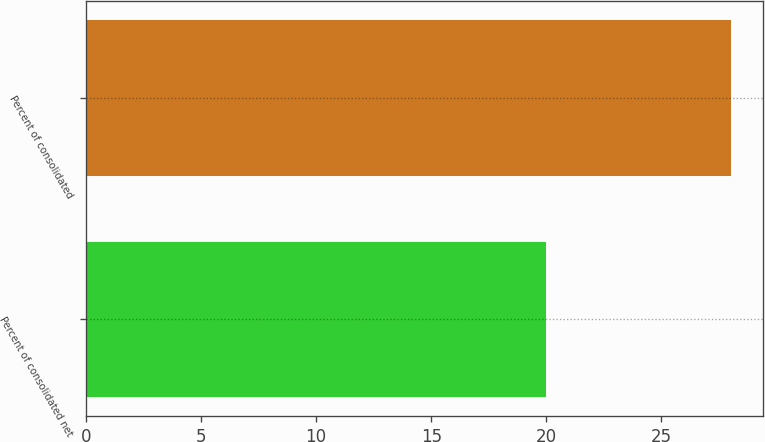Convert chart. <chart><loc_0><loc_0><loc_500><loc_500><bar_chart><fcel>Percent of consolidated net<fcel>Percent of consolidated<nl><fcel>20<fcel>28<nl></chart> 